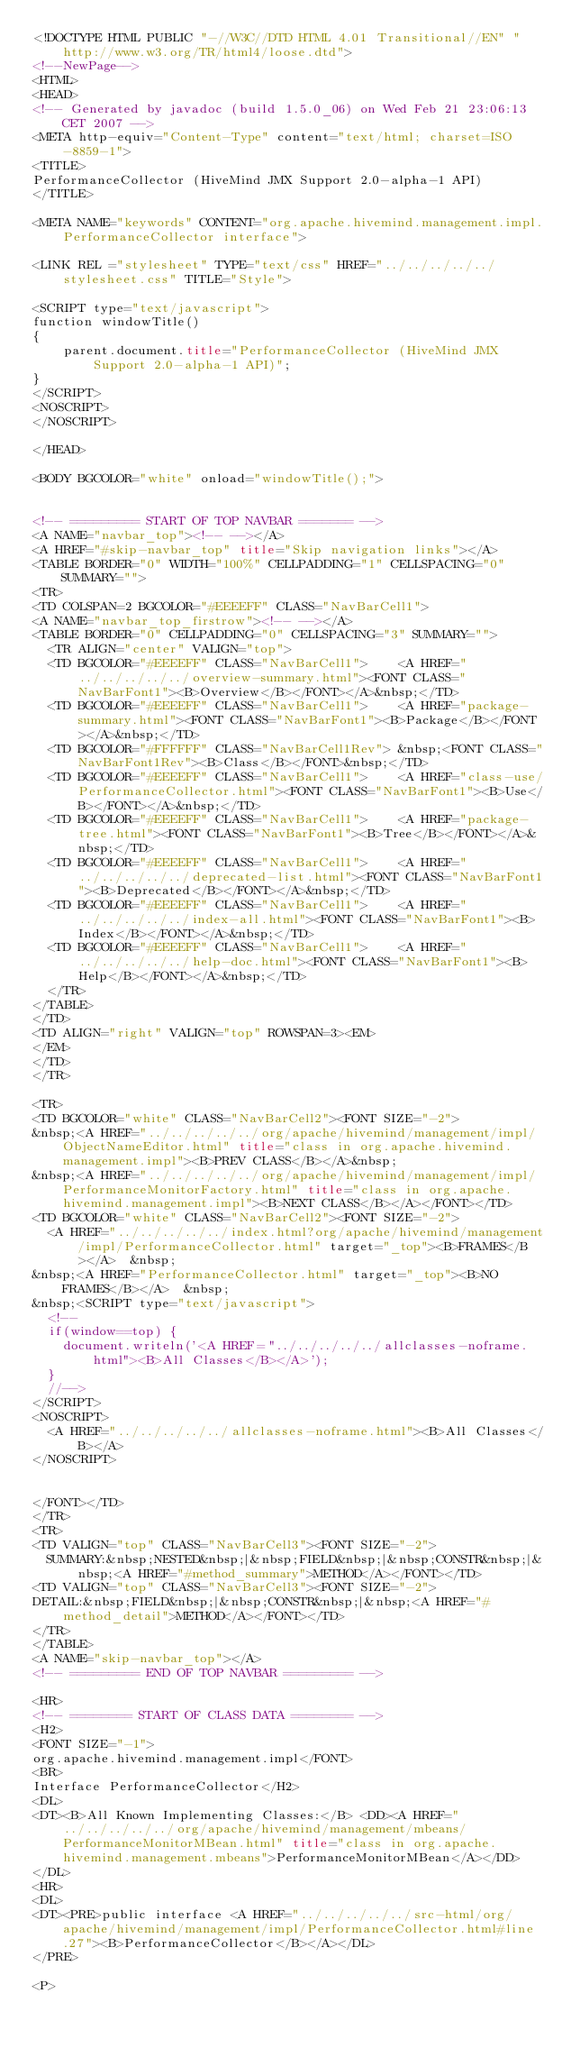<code> <loc_0><loc_0><loc_500><loc_500><_HTML_><!DOCTYPE HTML PUBLIC "-//W3C//DTD HTML 4.01 Transitional//EN" "http://www.w3.org/TR/html4/loose.dtd">
<!--NewPage-->
<HTML>
<HEAD>
<!-- Generated by javadoc (build 1.5.0_06) on Wed Feb 21 23:06:13 CET 2007 -->
<META http-equiv="Content-Type" content="text/html; charset=ISO-8859-1">
<TITLE>
PerformanceCollector (HiveMind JMX Support 2.0-alpha-1 API)
</TITLE>

<META NAME="keywords" CONTENT="org.apache.hivemind.management.impl.PerformanceCollector interface">

<LINK REL ="stylesheet" TYPE="text/css" HREF="../../../../../stylesheet.css" TITLE="Style">

<SCRIPT type="text/javascript">
function windowTitle()
{
    parent.document.title="PerformanceCollector (HiveMind JMX Support 2.0-alpha-1 API)";
}
</SCRIPT>
<NOSCRIPT>
</NOSCRIPT>

</HEAD>

<BODY BGCOLOR="white" onload="windowTitle();">


<!-- ========= START OF TOP NAVBAR ======= -->
<A NAME="navbar_top"><!-- --></A>
<A HREF="#skip-navbar_top" title="Skip navigation links"></A>
<TABLE BORDER="0" WIDTH="100%" CELLPADDING="1" CELLSPACING="0" SUMMARY="">
<TR>
<TD COLSPAN=2 BGCOLOR="#EEEEFF" CLASS="NavBarCell1">
<A NAME="navbar_top_firstrow"><!-- --></A>
<TABLE BORDER="0" CELLPADDING="0" CELLSPACING="3" SUMMARY="">
  <TR ALIGN="center" VALIGN="top">
  <TD BGCOLOR="#EEEEFF" CLASS="NavBarCell1">    <A HREF="../../../../../overview-summary.html"><FONT CLASS="NavBarFont1"><B>Overview</B></FONT></A>&nbsp;</TD>
  <TD BGCOLOR="#EEEEFF" CLASS="NavBarCell1">    <A HREF="package-summary.html"><FONT CLASS="NavBarFont1"><B>Package</B></FONT></A>&nbsp;</TD>
  <TD BGCOLOR="#FFFFFF" CLASS="NavBarCell1Rev"> &nbsp;<FONT CLASS="NavBarFont1Rev"><B>Class</B></FONT>&nbsp;</TD>
  <TD BGCOLOR="#EEEEFF" CLASS="NavBarCell1">    <A HREF="class-use/PerformanceCollector.html"><FONT CLASS="NavBarFont1"><B>Use</B></FONT></A>&nbsp;</TD>
  <TD BGCOLOR="#EEEEFF" CLASS="NavBarCell1">    <A HREF="package-tree.html"><FONT CLASS="NavBarFont1"><B>Tree</B></FONT></A>&nbsp;</TD>
  <TD BGCOLOR="#EEEEFF" CLASS="NavBarCell1">    <A HREF="../../../../../deprecated-list.html"><FONT CLASS="NavBarFont1"><B>Deprecated</B></FONT></A>&nbsp;</TD>
  <TD BGCOLOR="#EEEEFF" CLASS="NavBarCell1">    <A HREF="../../../../../index-all.html"><FONT CLASS="NavBarFont1"><B>Index</B></FONT></A>&nbsp;</TD>
  <TD BGCOLOR="#EEEEFF" CLASS="NavBarCell1">    <A HREF="../../../../../help-doc.html"><FONT CLASS="NavBarFont1"><B>Help</B></FONT></A>&nbsp;</TD>
  </TR>
</TABLE>
</TD>
<TD ALIGN="right" VALIGN="top" ROWSPAN=3><EM>
</EM>
</TD>
</TR>

<TR>
<TD BGCOLOR="white" CLASS="NavBarCell2"><FONT SIZE="-2">
&nbsp;<A HREF="../../../../../org/apache/hivemind/management/impl/ObjectNameEditor.html" title="class in org.apache.hivemind.management.impl"><B>PREV CLASS</B></A>&nbsp;
&nbsp;<A HREF="../../../../../org/apache/hivemind/management/impl/PerformanceMonitorFactory.html" title="class in org.apache.hivemind.management.impl"><B>NEXT CLASS</B></A></FONT></TD>
<TD BGCOLOR="white" CLASS="NavBarCell2"><FONT SIZE="-2">
  <A HREF="../../../../../index.html?org/apache/hivemind/management/impl/PerformanceCollector.html" target="_top"><B>FRAMES</B></A>  &nbsp;
&nbsp;<A HREF="PerformanceCollector.html" target="_top"><B>NO FRAMES</B></A>  &nbsp;
&nbsp;<SCRIPT type="text/javascript">
  <!--
  if(window==top) {
    document.writeln('<A HREF="../../../../../allclasses-noframe.html"><B>All Classes</B></A>');
  }
  //-->
</SCRIPT>
<NOSCRIPT>
  <A HREF="../../../../../allclasses-noframe.html"><B>All Classes</B></A>
</NOSCRIPT>


</FONT></TD>
</TR>
<TR>
<TD VALIGN="top" CLASS="NavBarCell3"><FONT SIZE="-2">
  SUMMARY:&nbsp;NESTED&nbsp;|&nbsp;FIELD&nbsp;|&nbsp;CONSTR&nbsp;|&nbsp;<A HREF="#method_summary">METHOD</A></FONT></TD>
<TD VALIGN="top" CLASS="NavBarCell3"><FONT SIZE="-2">
DETAIL:&nbsp;FIELD&nbsp;|&nbsp;CONSTR&nbsp;|&nbsp;<A HREF="#method_detail">METHOD</A></FONT></TD>
</TR>
</TABLE>
<A NAME="skip-navbar_top"></A>
<!-- ========= END OF TOP NAVBAR ========= -->

<HR>
<!-- ======== START OF CLASS DATA ======== -->
<H2>
<FONT SIZE="-1">
org.apache.hivemind.management.impl</FONT>
<BR>
Interface PerformanceCollector</H2>
<DL>
<DT><B>All Known Implementing Classes:</B> <DD><A HREF="../../../../../org/apache/hivemind/management/mbeans/PerformanceMonitorMBean.html" title="class in org.apache.hivemind.management.mbeans">PerformanceMonitorMBean</A></DD>
</DL>
<HR>
<DL>
<DT><PRE>public interface <A HREF="../../../../../src-html/org/apache/hivemind/management/impl/PerformanceCollector.html#line.27"><B>PerformanceCollector</B></A></DL>
</PRE>

<P></code> 